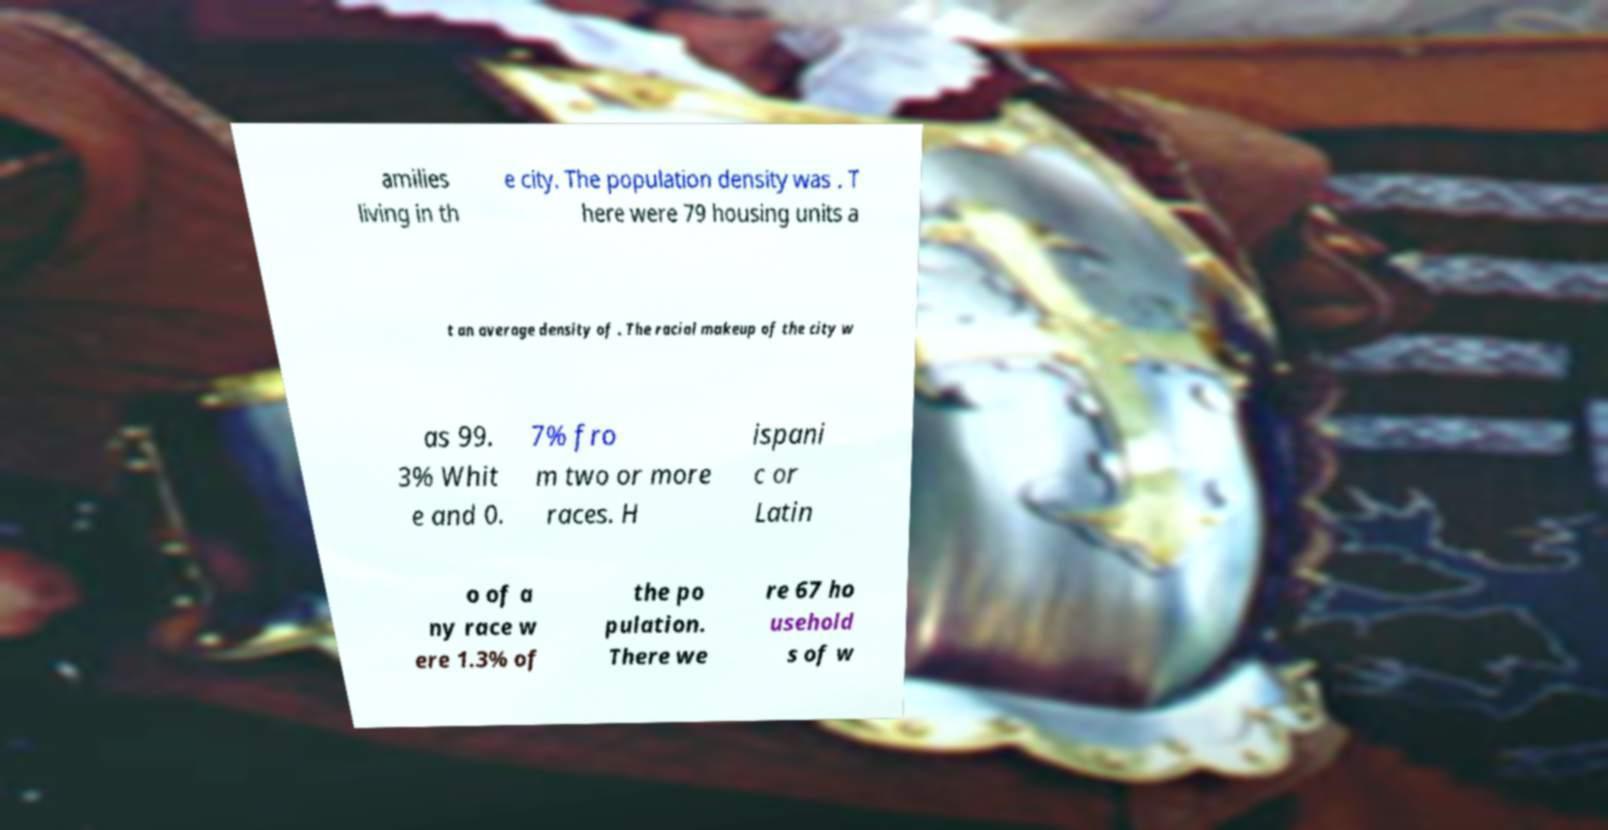What messages or text are displayed in this image? I need them in a readable, typed format. amilies living in th e city. The population density was . T here were 79 housing units a t an average density of . The racial makeup of the city w as 99. 3% Whit e and 0. 7% fro m two or more races. H ispani c or Latin o of a ny race w ere 1.3% of the po pulation. There we re 67 ho usehold s of w 